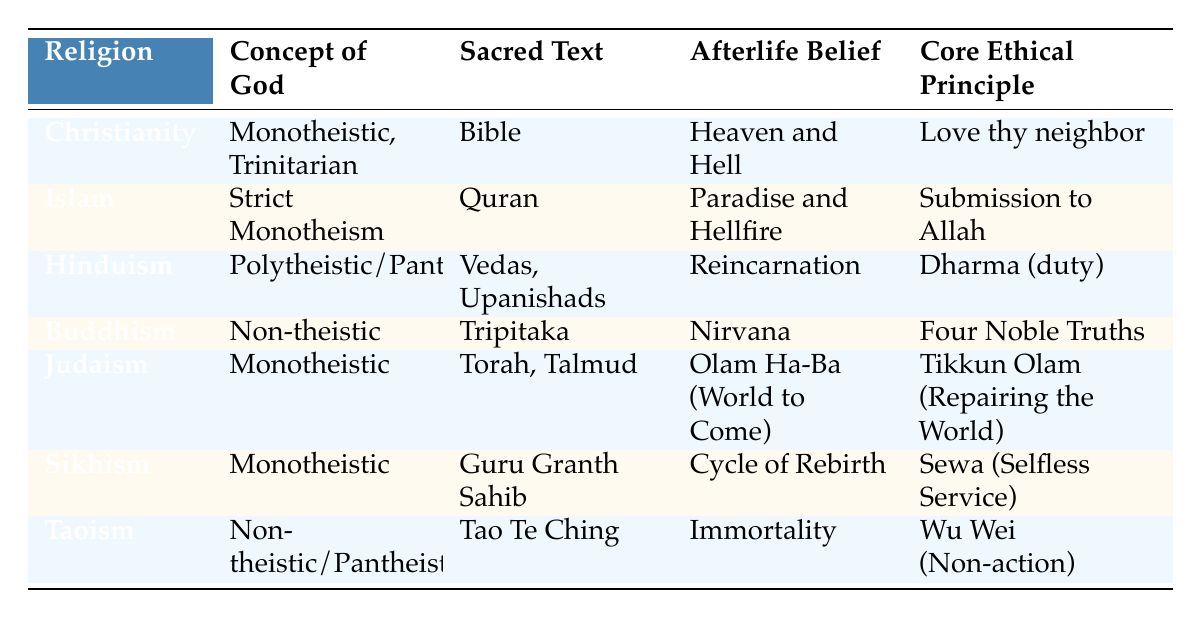What is the sacred text of Buddhism? According to the table, the sacred text associated with Buddhism is the Tripitaka.
Answer: Tripitaka Which religion believes in reincarnation? The table indicates that Hinduism has a belief in reincarnation as part of its afterlife belief.
Answer: Hinduism Is the concept of God in Sikhism polytheistic? In the table, Sikhism is described as monotheistic, so this statement is false.
Answer: No What do both Christianity and Judaism have in common regarding their concept of God? Both Christianity and Judaism share the characteristic of being monotheistic, as represented in the table.
Answer: Monotheistic Which religion has the core ethical principle of "Dharma (duty)"? The table shows that Hinduism is associated with the core ethical principle of "Dharma (duty)."
Answer: Hinduism What is the afterlife belief for Islam? The table states that Islam believes in Paradise and Hellfire as its afterlife belief.
Answer: Paradise and Hellfire Are there more religions that follow a non-theistic concept of God than those that are strictly monotheistic? Upon examining the table, Buddhism and Taoism follow a non-theistic approach, while only three (Christianity, Islam, Judaism) adhere strictly to monotheism. Therefore, there are more non-theistic religions (2) than strictly monotheistic religions (3).
Answer: No Which sacred text do both Judaism and Christianity refer to? The table lists the Torah for Judaism, and while the Bible is the main text for Christianity, the Old Testament of the Bible is derived from the Torah. Therefore, they share a common text.
Answer: Torah Which religion focuses on "Sewa (Selfless Service)" as its core ethical principle? In the table, Sikhism is identified as having "Sewa (Selfless Service)" as its core ethical principle.
Answer: Sikhism 